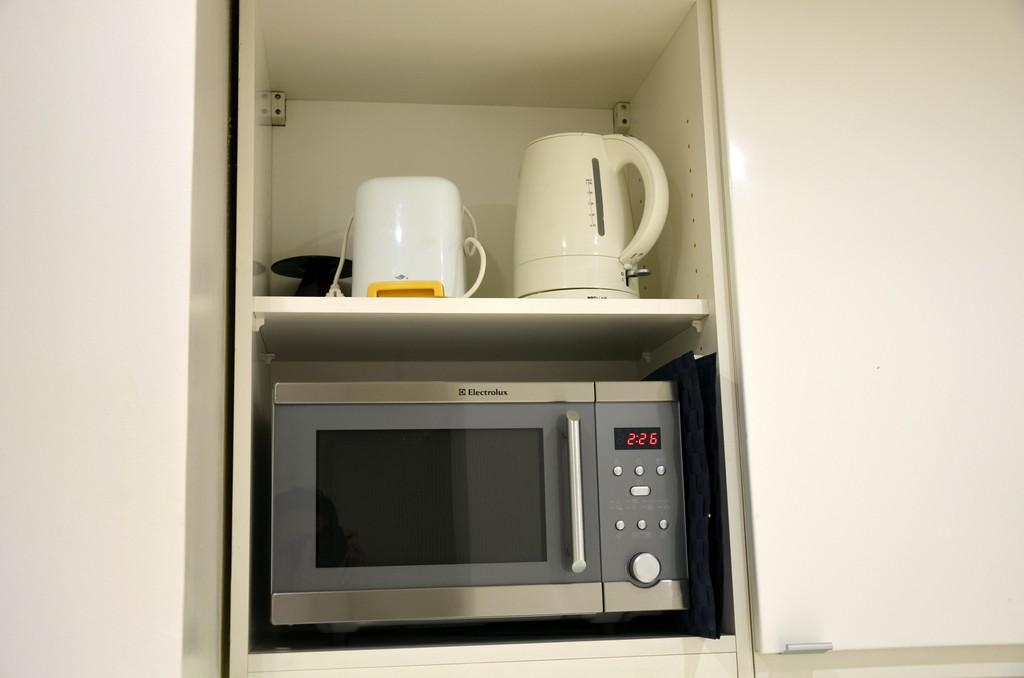<image>
Provide a brief description of the given image. An Electrolux microwave sits on a shelf showing the time of 2:26. 